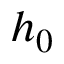<formula> <loc_0><loc_0><loc_500><loc_500>h _ { 0 }</formula> 